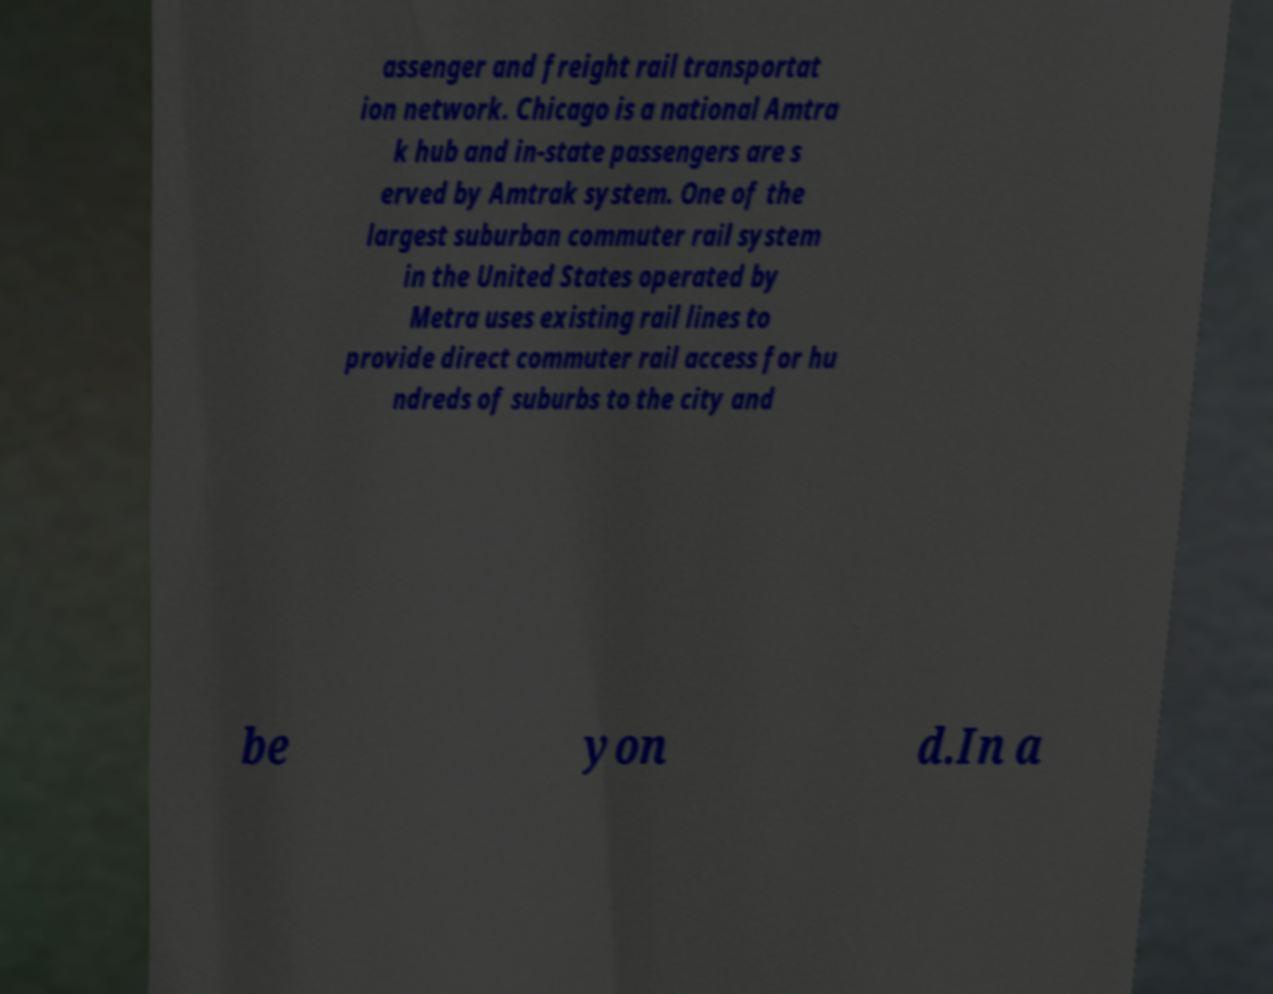There's text embedded in this image that I need extracted. Can you transcribe it verbatim? assenger and freight rail transportat ion network. Chicago is a national Amtra k hub and in-state passengers are s erved by Amtrak system. One of the largest suburban commuter rail system in the United States operated by Metra uses existing rail lines to provide direct commuter rail access for hu ndreds of suburbs to the city and be yon d.In a 